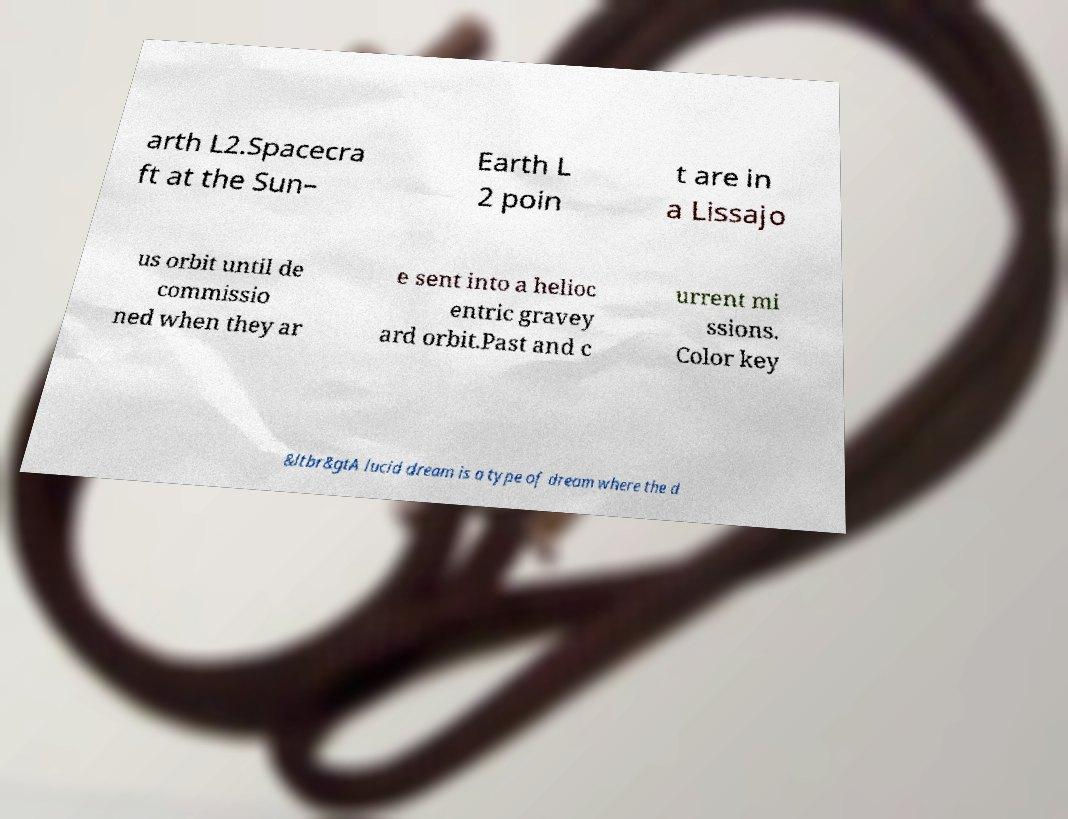Could you assist in decoding the text presented in this image and type it out clearly? arth L2.Spacecra ft at the Sun– Earth L 2 poin t are in a Lissajo us orbit until de commissio ned when they ar e sent into a helioc entric gravey ard orbit.Past and c urrent mi ssions. Color key &ltbr&gtA lucid dream is a type of dream where the d 